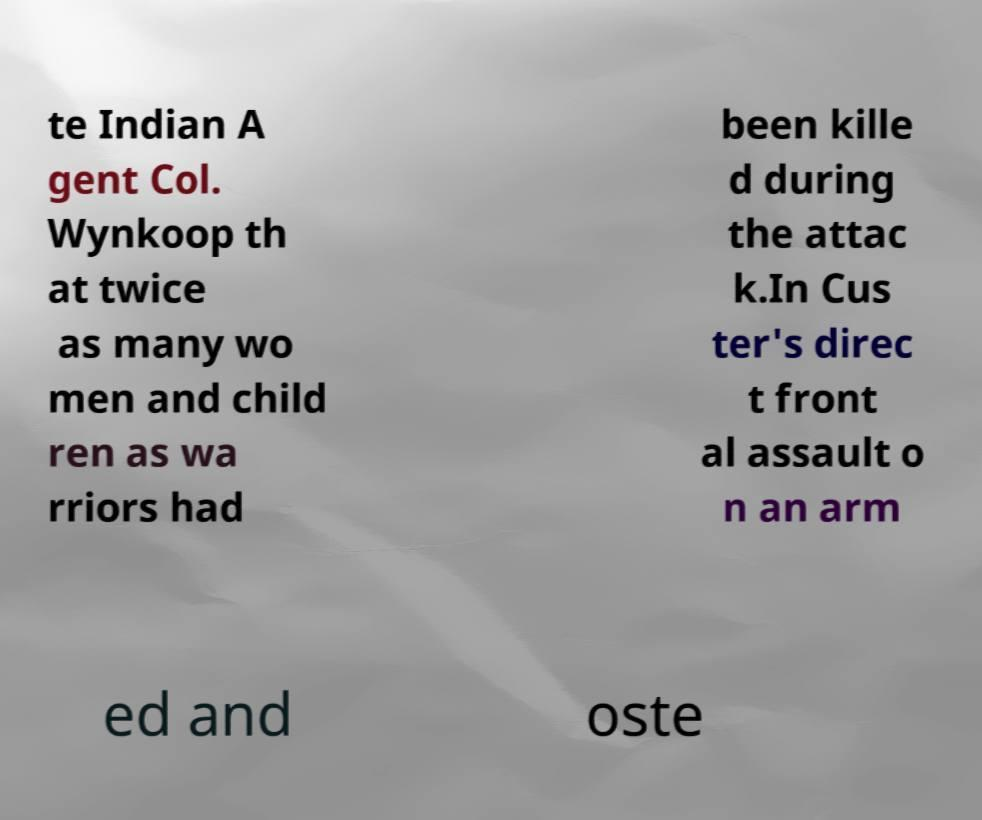For documentation purposes, I need the text within this image transcribed. Could you provide that? te Indian A gent Col. Wynkoop th at twice as many wo men and child ren as wa rriors had been kille d during the attac k.In Cus ter's direc t front al assault o n an arm ed and oste 